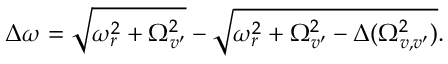Convert formula to latex. <formula><loc_0><loc_0><loc_500><loc_500>\Delta \omega = \sqrt { \omega _ { r } ^ { 2 } + \Omega _ { v ^ { \prime } } ^ { 2 } } - \sqrt { \omega _ { r } ^ { 2 } + \Omega _ { v ^ { \prime } } ^ { 2 } - \Delta ( \Omega _ { v , v ^ { \prime } } ^ { 2 } ) } .</formula> 